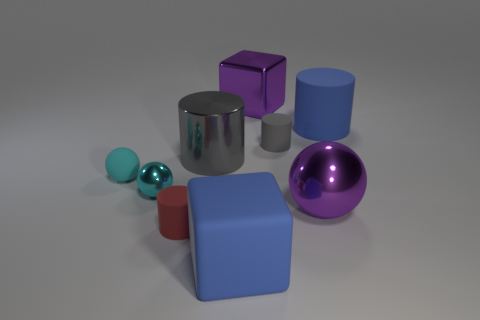How many other things are there of the same size as the cyan metal thing?
Ensure brevity in your answer.  3. Are there an equal number of large spheres that are behind the tiny gray matte thing and tiny cyan metal spheres to the right of the tiny cyan metal sphere?
Keep it short and to the point. Yes. There is a large matte thing that is the same shape as the small gray rubber object; what is its color?
Your response must be concise. Blue. Is there any other thing that is the same shape as the small metallic thing?
Give a very brief answer. Yes. Does the large cube behind the small red cylinder have the same color as the big rubber cylinder?
Offer a very short reply. No. There is a purple metallic object that is the same shape as the cyan rubber object; what is its size?
Give a very brief answer. Large. What number of other tiny objects have the same material as the red thing?
Provide a short and direct response. 2. There is a large purple sphere on the right side of the block that is on the left side of the large metal block; is there a purple metal block to the right of it?
Your answer should be compact. No. There is a red matte thing; what shape is it?
Make the answer very short. Cylinder. Does the block in front of the big blue cylinder have the same material as the tiny cyan object in front of the cyan matte sphere?
Make the answer very short. No. 